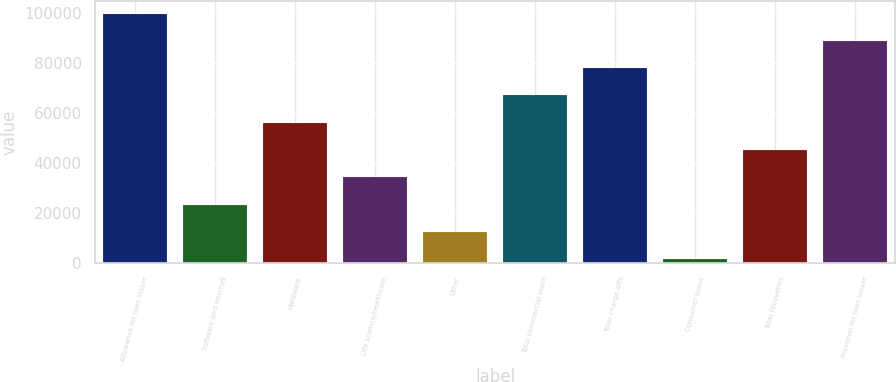Convert chart to OTSL. <chart><loc_0><loc_0><loc_500><loc_500><bar_chart><fcel>Allowance for loan losses<fcel>Software and internet<fcel>Hardware<fcel>Life science/healthcare<fcel>Other<fcel>Total commercial loans<fcel>Total charge-offs<fcel>Consumer loans<fcel>Total recoveries<fcel>Provision for loan losses<nl><fcel>99721<fcel>23211<fcel>56001<fcel>34141<fcel>12281<fcel>66931<fcel>77861<fcel>1351<fcel>45071<fcel>88791<nl></chart> 